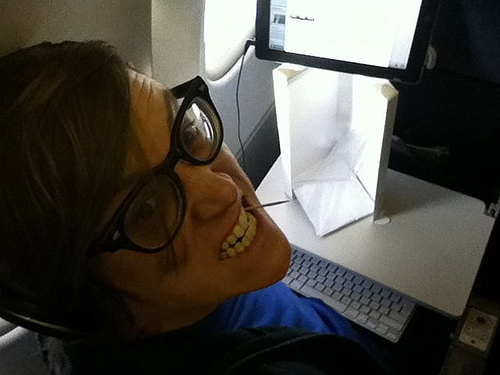Do you see any white bowls or tables? Yes, there is a white table present in the image. 